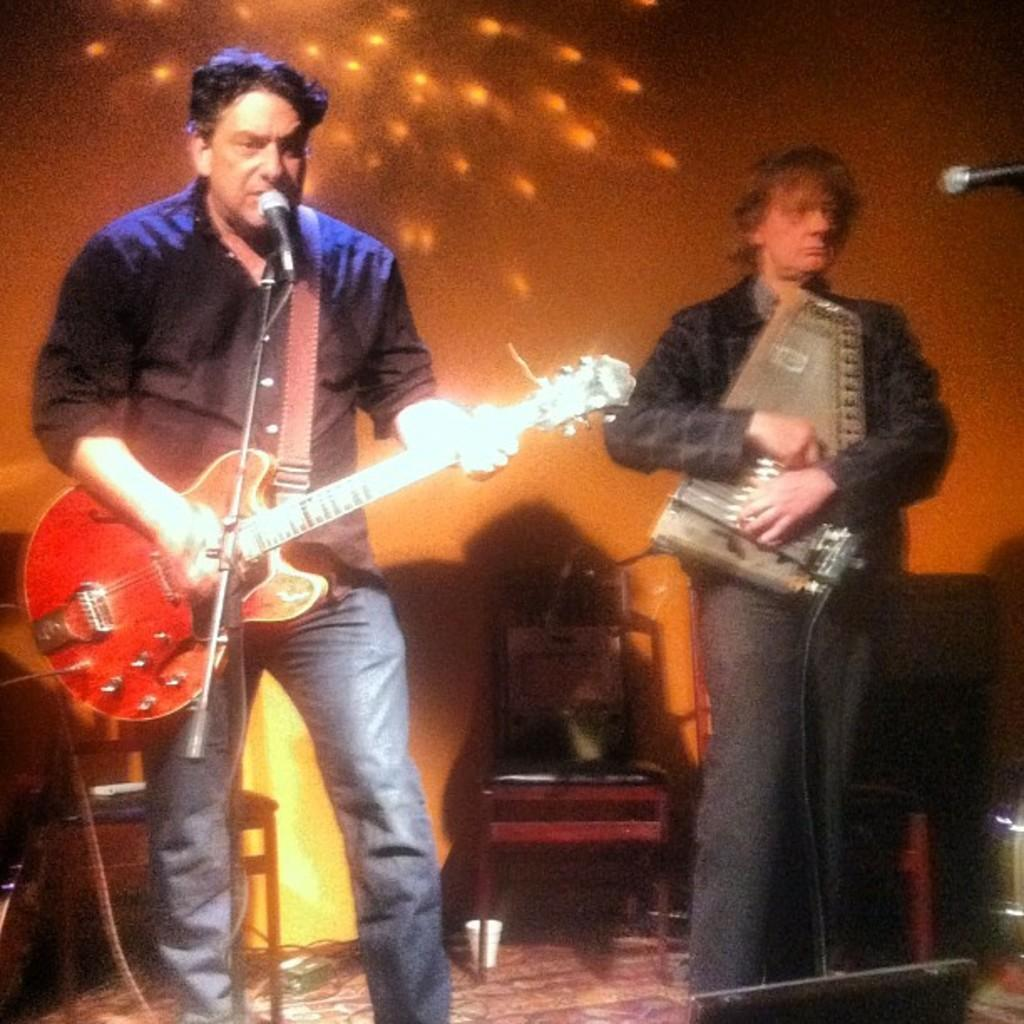What is the person wearing in the image? The person is wearing blue jeans in the image. What activity is the person engaged in? The person is playing a guitar and singing in the image. What object is the person in front of? The person is in front of a microphone. Are there any other people in the image? Yes, there is another person in the image. What is the second person doing? The second person is playing a musical instrument. What type of writing is the person doing in the image? There is no writing activity depicted in the image; the person is playing a guitar and singing. Is the person in the image a minister? The image does not provide any information about the person's occupation or religious affiliation. 